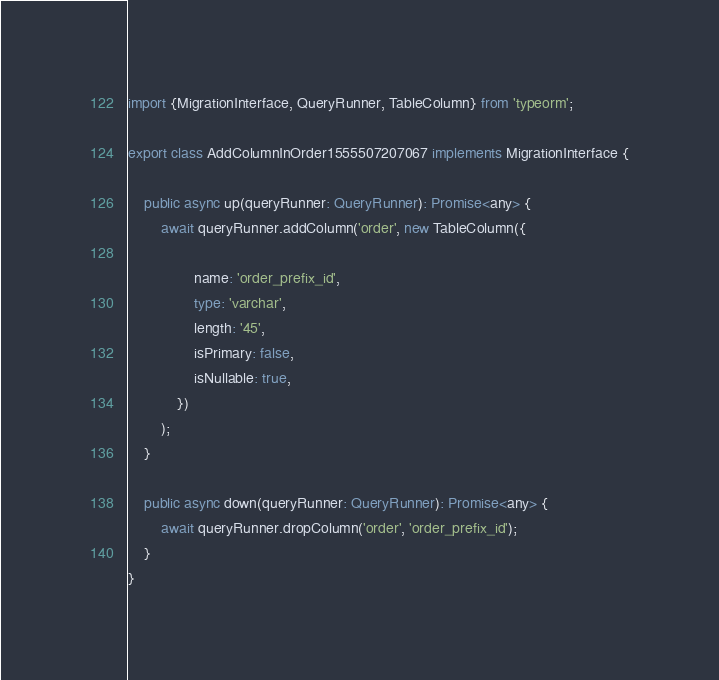Convert code to text. <code><loc_0><loc_0><loc_500><loc_500><_TypeScript_>import {MigrationInterface, QueryRunner, TableColumn} from 'typeorm';

export class AddColumnInOrder1555507207067 implements MigrationInterface {

    public async up(queryRunner: QueryRunner): Promise<any> {
        await queryRunner.addColumn('order', new TableColumn({

                name: 'order_prefix_id',
                type: 'varchar',
                length: '45',
                isPrimary: false,
                isNullable: true,
            })
        );
    }

    public async down(queryRunner: QueryRunner): Promise<any> {
        await queryRunner.dropColumn('order', 'order_prefix_id');
    }
}
</code> 